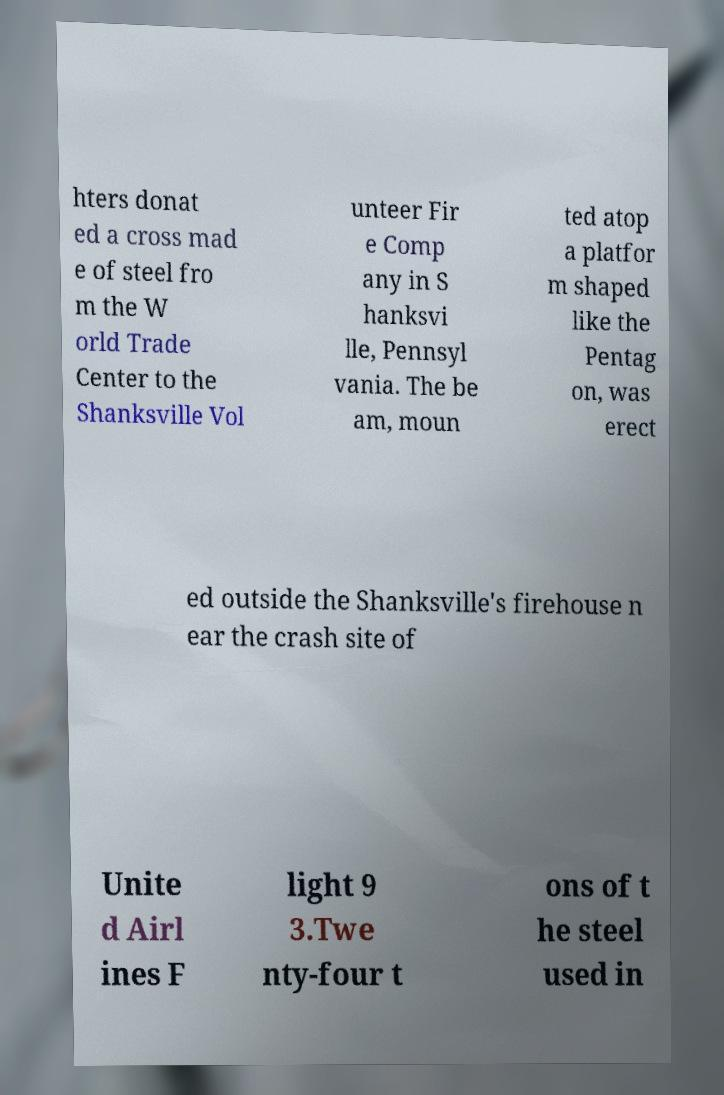Can you accurately transcribe the text from the provided image for me? hters donat ed a cross mad e of steel fro m the W orld Trade Center to the Shanksville Vol unteer Fir e Comp any in S hanksvi lle, Pennsyl vania. The be am, moun ted atop a platfor m shaped like the Pentag on, was erect ed outside the Shanksville's firehouse n ear the crash site of Unite d Airl ines F light 9 3.Twe nty-four t ons of t he steel used in 